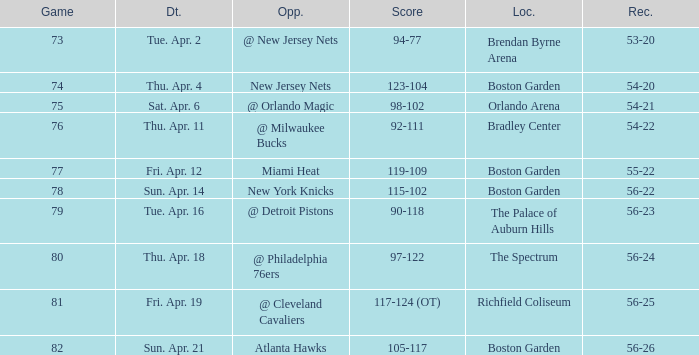Where was game 78 held? Boston Garden. 